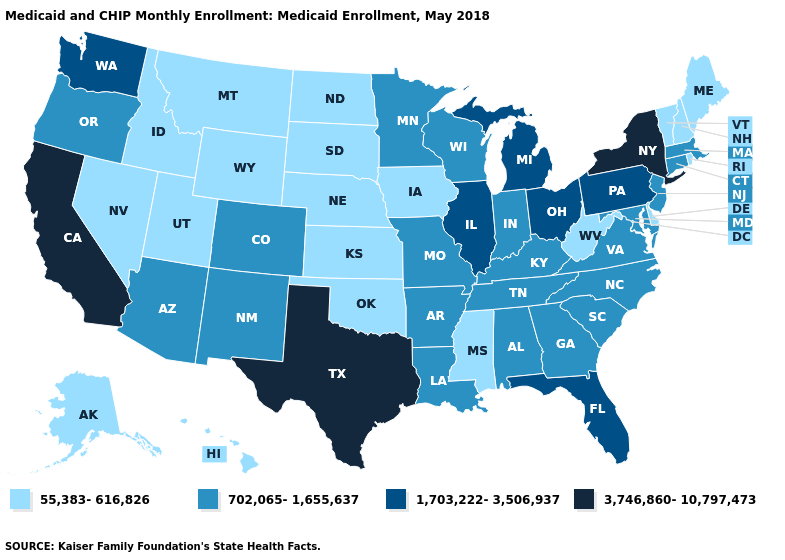Name the states that have a value in the range 55,383-616,826?
Short answer required. Alaska, Delaware, Hawaii, Idaho, Iowa, Kansas, Maine, Mississippi, Montana, Nebraska, Nevada, New Hampshire, North Dakota, Oklahoma, Rhode Island, South Dakota, Utah, Vermont, West Virginia, Wyoming. Name the states that have a value in the range 55,383-616,826?
Be succinct. Alaska, Delaware, Hawaii, Idaho, Iowa, Kansas, Maine, Mississippi, Montana, Nebraska, Nevada, New Hampshire, North Dakota, Oklahoma, Rhode Island, South Dakota, Utah, Vermont, West Virginia, Wyoming. Does North Carolina have a lower value than Illinois?
Give a very brief answer. Yes. Which states have the highest value in the USA?
Give a very brief answer. California, New York, Texas. What is the highest value in the MidWest ?
Give a very brief answer. 1,703,222-3,506,937. Does Montana have a lower value than Oklahoma?
Short answer required. No. Name the states that have a value in the range 55,383-616,826?
Keep it brief. Alaska, Delaware, Hawaii, Idaho, Iowa, Kansas, Maine, Mississippi, Montana, Nebraska, Nevada, New Hampshire, North Dakota, Oklahoma, Rhode Island, South Dakota, Utah, Vermont, West Virginia, Wyoming. Among the states that border New York , which have the lowest value?
Concise answer only. Vermont. Name the states that have a value in the range 55,383-616,826?
Quick response, please. Alaska, Delaware, Hawaii, Idaho, Iowa, Kansas, Maine, Mississippi, Montana, Nebraska, Nevada, New Hampshire, North Dakota, Oklahoma, Rhode Island, South Dakota, Utah, Vermont, West Virginia, Wyoming. Among the states that border Minnesota , which have the highest value?
Give a very brief answer. Wisconsin. Among the states that border Maryland , which have the highest value?
Write a very short answer. Pennsylvania. Does the first symbol in the legend represent the smallest category?
Be succinct. Yes. What is the lowest value in states that border Delaware?
Answer briefly. 702,065-1,655,637. Among the states that border Delaware , which have the lowest value?
Keep it brief. Maryland, New Jersey. How many symbols are there in the legend?
Be succinct. 4. 